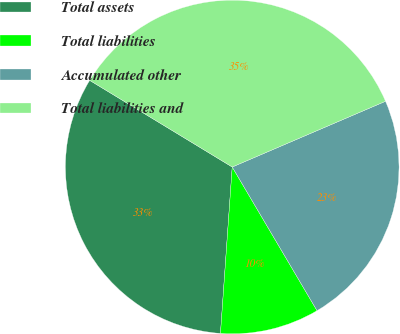Convert chart. <chart><loc_0><loc_0><loc_500><loc_500><pie_chart><fcel>Total assets<fcel>Total liabilities<fcel>Accumulated other<fcel>Total liabilities and<nl><fcel>32.57%<fcel>9.61%<fcel>22.96%<fcel>34.86%<nl></chart> 